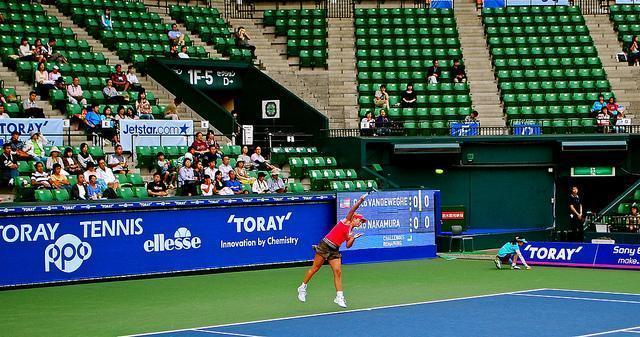How many people can you see?
Give a very brief answer. 2. 